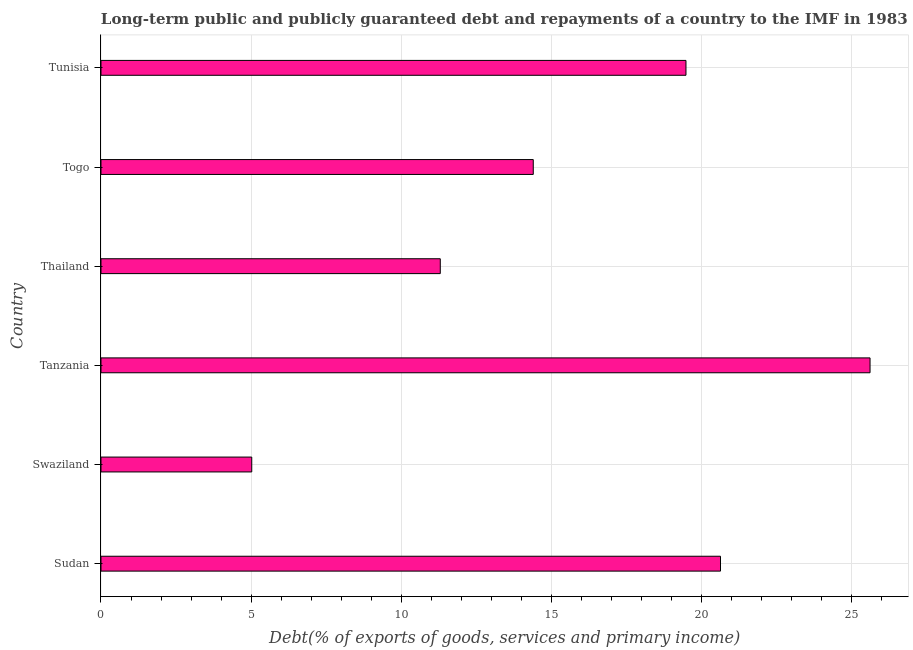Does the graph contain any zero values?
Provide a short and direct response. No. What is the title of the graph?
Your response must be concise. Long-term public and publicly guaranteed debt and repayments of a country to the IMF in 1983. What is the label or title of the X-axis?
Your response must be concise. Debt(% of exports of goods, services and primary income). What is the debt service in Tanzania?
Your response must be concise. 25.63. Across all countries, what is the maximum debt service?
Your answer should be compact. 25.63. Across all countries, what is the minimum debt service?
Keep it short and to the point. 5.02. In which country was the debt service maximum?
Keep it short and to the point. Tanzania. In which country was the debt service minimum?
Offer a terse response. Swaziland. What is the sum of the debt service?
Make the answer very short. 96.5. What is the difference between the debt service in Swaziland and Togo?
Provide a succinct answer. -9.38. What is the average debt service per country?
Give a very brief answer. 16.08. What is the median debt service?
Your answer should be compact. 16.95. What is the ratio of the debt service in Swaziland to that in Tanzania?
Your answer should be compact. 0.2. Is the debt service in Thailand less than that in Togo?
Ensure brevity in your answer.  Yes. Is the difference between the debt service in Sudan and Tanzania greater than the difference between any two countries?
Offer a very short reply. No. What is the difference between the highest and the second highest debt service?
Provide a short and direct response. 4.98. Is the sum of the debt service in Thailand and Togo greater than the maximum debt service across all countries?
Offer a very short reply. Yes. What is the difference between the highest and the lowest debt service?
Make the answer very short. 20.6. Are the values on the major ticks of X-axis written in scientific E-notation?
Offer a very short reply. No. What is the Debt(% of exports of goods, services and primary income) in Sudan?
Ensure brevity in your answer.  20.64. What is the Debt(% of exports of goods, services and primary income) of Swaziland?
Make the answer very short. 5.02. What is the Debt(% of exports of goods, services and primary income) in Tanzania?
Your response must be concise. 25.63. What is the Debt(% of exports of goods, services and primary income) in Thailand?
Provide a short and direct response. 11.31. What is the Debt(% of exports of goods, services and primary income) in Togo?
Provide a short and direct response. 14.4. What is the Debt(% of exports of goods, services and primary income) of Tunisia?
Your response must be concise. 19.49. What is the difference between the Debt(% of exports of goods, services and primary income) in Sudan and Swaziland?
Your response must be concise. 15.62. What is the difference between the Debt(% of exports of goods, services and primary income) in Sudan and Tanzania?
Provide a succinct answer. -4.98. What is the difference between the Debt(% of exports of goods, services and primary income) in Sudan and Thailand?
Your response must be concise. 9.34. What is the difference between the Debt(% of exports of goods, services and primary income) in Sudan and Togo?
Your answer should be compact. 6.24. What is the difference between the Debt(% of exports of goods, services and primary income) in Sudan and Tunisia?
Keep it short and to the point. 1.15. What is the difference between the Debt(% of exports of goods, services and primary income) in Swaziland and Tanzania?
Your answer should be compact. -20.6. What is the difference between the Debt(% of exports of goods, services and primary income) in Swaziland and Thailand?
Provide a short and direct response. -6.28. What is the difference between the Debt(% of exports of goods, services and primary income) in Swaziland and Togo?
Give a very brief answer. -9.38. What is the difference between the Debt(% of exports of goods, services and primary income) in Swaziland and Tunisia?
Keep it short and to the point. -14.47. What is the difference between the Debt(% of exports of goods, services and primary income) in Tanzania and Thailand?
Ensure brevity in your answer.  14.32. What is the difference between the Debt(% of exports of goods, services and primary income) in Tanzania and Togo?
Your answer should be compact. 11.22. What is the difference between the Debt(% of exports of goods, services and primary income) in Tanzania and Tunisia?
Ensure brevity in your answer.  6.13. What is the difference between the Debt(% of exports of goods, services and primary income) in Thailand and Togo?
Your response must be concise. -3.1. What is the difference between the Debt(% of exports of goods, services and primary income) in Thailand and Tunisia?
Give a very brief answer. -8.19. What is the difference between the Debt(% of exports of goods, services and primary income) in Togo and Tunisia?
Keep it short and to the point. -5.09. What is the ratio of the Debt(% of exports of goods, services and primary income) in Sudan to that in Swaziland?
Provide a short and direct response. 4.11. What is the ratio of the Debt(% of exports of goods, services and primary income) in Sudan to that in Tanzania?
Offer a terse response. 0.81. What is the ratio of the Debt(% of exports of goods, services and primary income) in Sudan to that in Thailand?
Make the answer very short. 1.83. What is the ratio of the Debt(% of exports of goods, services and primary income) in Sudan to that in Togo?
Your answer should be compact. 1.43. What is the ratio of the Debt(% of exports of goods, services and primary income) in Sudan to that in Tunisia?
Keep it short and to the point. 1.06. What is the ratio of the Debt(% of exports of goods, services and primary income) in Swaziland to that in Tanzania?
Ensure brevity in your answer.  0.2. What is the ratio of the Debt(% of exports of goods, services and primary income) in Swaziland to that in Thailand?
Your answer should be compact. 0.44. What is the ratio of the Debt(% of exports of goods, services and primary income) in Swaziland to that in Togo?
Ensure brevity in your answer.  0.35. What is the ratio of the Debt(% of exports of goods, services and primary income) in Swaziland to that in Tunisia?
Ensure brevity in your answer.  0.26. What is the ratio of the Debt(% of exports of goods, services and primary income) in Tanzania to that in Thailand?
Provide a succinct answer. 2.27. What is the ratio of the Debt(% of exports of goods, services and primary income) in Tanzania to that in Togo?
Offer a terse response. 1.78. What is the ratio of the Debt(% of exports of goods, services and primary income) in Tanzania to that in Tunisia?
Provide a short and direct response. 1.31. What is the ratio of the Debt(% of exports of goods, services and primary income) in Thailand to that in Togo?
Give a very brief answer. 0.79. What is the ratio of the Debt(% of exports of goods, services and primary income) in Thailand to that in Tunisia?
Give a very brief answer. 0.58. What is the ratio of the Debt(% of exports of goods, services and primary income) in Togo to that in Tunisia?
Offer a very short reply. 0.74. 